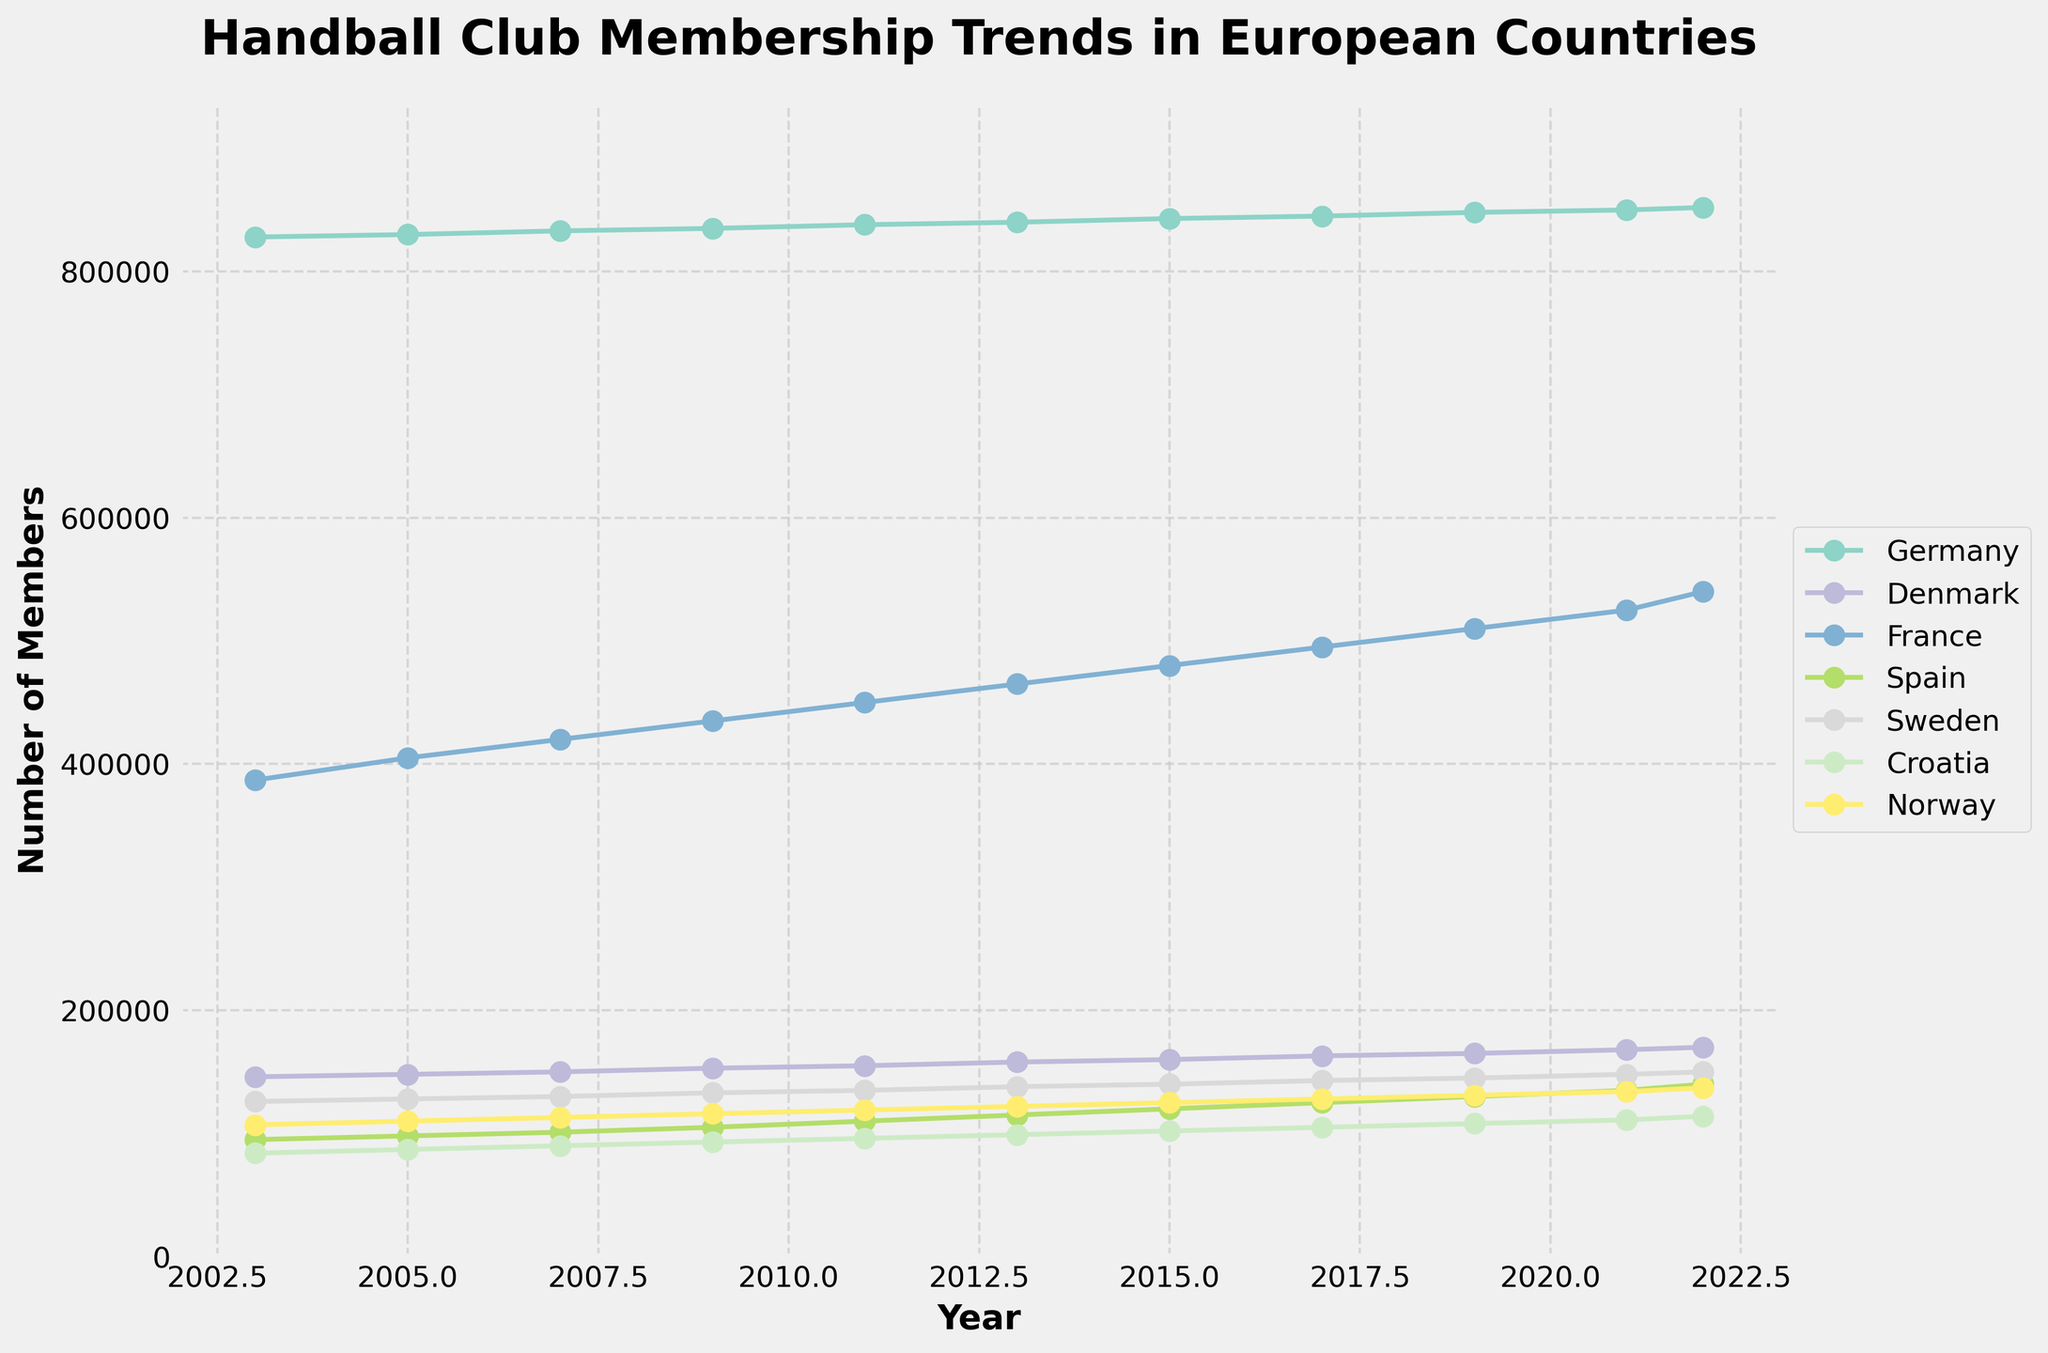What was the trend of handball club membership numbers in France over the last 20 years? France's handball club membership numbers consistently increased over the last 20 years. Starting from 387,000 members in 2003, the numbers rose each subsequent year, reaching 540,000 in 2022.
Answer: France showed a steady increase in membership numbers from 387,000 in 2003 to 540,000 in 2022 Which country had the highest number of handball club members in 2022, and what was the number? In 2022, Germany had the highest number of handball club members. Observing the figure, the line representing Germany is the highest among all countries, showing a membership number of 852,000.
Answer: Germany with 852,000 members What was the overall membership growth in Croatia from 2003 to 2022? In 2003, Croatia had 84,000 members. By 2022, this number increased to 114,000. The overall growth is calculated as 114,000 - 84,000 = 30,000.
Answer: 30,000 Compare the membership trends between Denmark and Norway from 2003 to 2022. Which country had a higher percentage increase? Denmark had 146,000 members in 2003 and 170,000 in 2022, while Norway had 107,000 in 2003 and 137,000 in 2022. The percentage increase for Denmark is ((170,000 - 146,000) / 146,000) * 100 ≈ 16.44%. For Norway, it's ((137,000 - 107,000) / 107,000) * 100 ≈ 28.04%.
Answer: Norway had a higher percentage increase What is the average number of handball club members in Sweden over the 20-year period? To find the average, sum the membership numbers for Sweden from each year (126,000 + 128,000 + 130,000 + 133,000 + 135,000 + 138,000 + 140,000 + 143,000 + 145,000 + 148,000 + 150,000) and divide by the number of years (11). The sum is 1,446,000, so the average is 1,446,000 / 11 ≈ 131,455 members.
Answer: 131,455 Which year saw the smallest membership number in Spain, and what was the number? Observing the figure, the smallest membership number for Spain occurred in 2003, with a value of 95,000 members.
Answer: 2003 with 95,000 members How did the membership trends in Germany and France compare in terms of absolute growth from 2003 to 2022? Germany had 828,000 members in 2003 and 852,000 in 2022, resulting in an absolute growth of 852,000 - 828,000 = 24,000. France had 387,000 members in 2003 and 540,000 in 2022, resulting in an absolute growth of 540,000 - 387,000 = 153,000.
Answer: France had greater absolute growth Which two countries have the most similar membership number trends over the 20 years? Observing the visual patterns of the lines, Denmark and Sweden display the most similar membership number trends, both showing steady increases with similar slopes.
Answer: Denmark and Sweden In which year did Norway's membership number reach 125,000, and how does it compare to Germany's number in the same year? Norway reached 125,000 members in 2015, as shown in the figure. In the same year, Germany's number was 843,000 members, thus Germany had 843,000 - 125,000 = 718,000 more members than Norway in 2015.
Answer: In 2015, Norway had 125,000, and Germany had 843,000, which is 718,000 more 